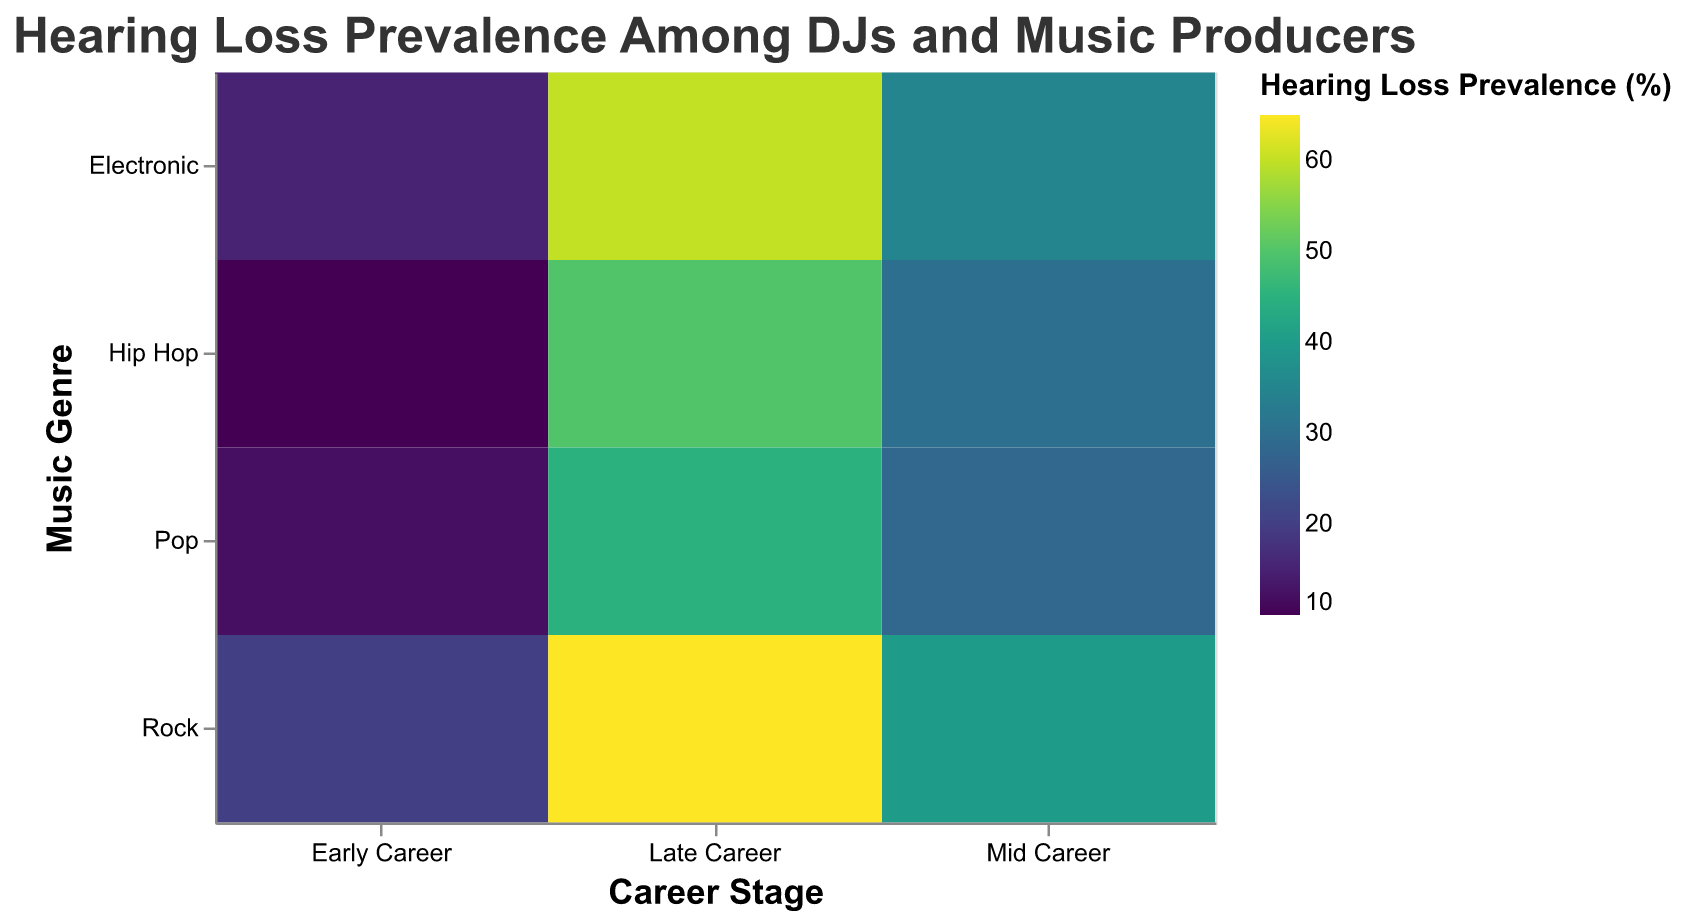Which Career Stage and Music Genre combination has the highest Hearing Loss Prevalence? Analyze the color intensity for all combinations to identify the darkest one, as darker colors represent higher prevalence. Rock musicians at the Late Career stage have the highest prevalence with 65%.
Answer: Late Career, Rock Which Career Stage and Music Genre combination has the lowest Hearing Loss Prevalence? Look for the lightest colored cell in the plot, as lighter colors represent lower prevalence. Hip Hop musicians at the Early Career stage have the lowest prevalence with 10%.
Answer: Early Career, Hip Hop How does Hearing Loss Prevalence change across Career Stages for DJs in the Electronic genre? Observe the color gradient in the Electronic genre row from left to right. Hearing loss prevalence increases from 15% in Early Career to 35% in Mid Career, and further to 60% in Late Career.
Answer: 15%, 35%, 60% What is the average Hearing Loss Prevalence for Pop musicians across all Career Stages? Calculate the average of the values for Pop in Early Career (12%), Mid Career (28%), and Late Career (45%). Average = (12 + 28 + 45) / 3 = 28.33%
Answer: 28.33% Which genre has the highest overall increase in Hearing Loss Prevalence from Early Career to Late Career? Calculate the difference between Late Career and Early Career for each genre and compare. Rock increases by 65% - 20% = 45%, which is the highest.
Answer: Rock How does the Hearing Loss Prevalence in the Mid Career stage of Hip Hop compare to that in the Early Career stage of Rock? Compare the values directly. Mid Career Hip Hop is 30% and Early Career Rock is 20%. 30% is greater than 20%.
Answer: Mid Career Hip Hop is higher Which Musical Genre shows the most significant jump in Hearing Loss Prevalence from Mid Career to Late Career? Calculate the jump for each genre from Mid to Late Career stages. Electronic jumps from 35% to 60% (25%), Hip Hop from 30% to 50% (20%), Rock from 40% to 65% (25%), and Pop from 28% to 45% (17%). Electronic and Rock both show the most significant jump of 25%.
Answer: Electronic and Rock What is the general trend observed for Hearing Loss Prevalence as DJs and music producers advance in their careers, regardless of genre? Observe the color gradient from left (Early Career) to right (Late Career) for all genres. Prevalence generally increases as career stage advances.
Answer: Increases What is the range of Hearing Loss Prevalence observed in the Late Career stage across all genres? Identify the lowest and highest prevalence within the Late Career stage for all genres. The range is from 45% (Pop) to 65% (Rock).
Answer: 45% to 65% 